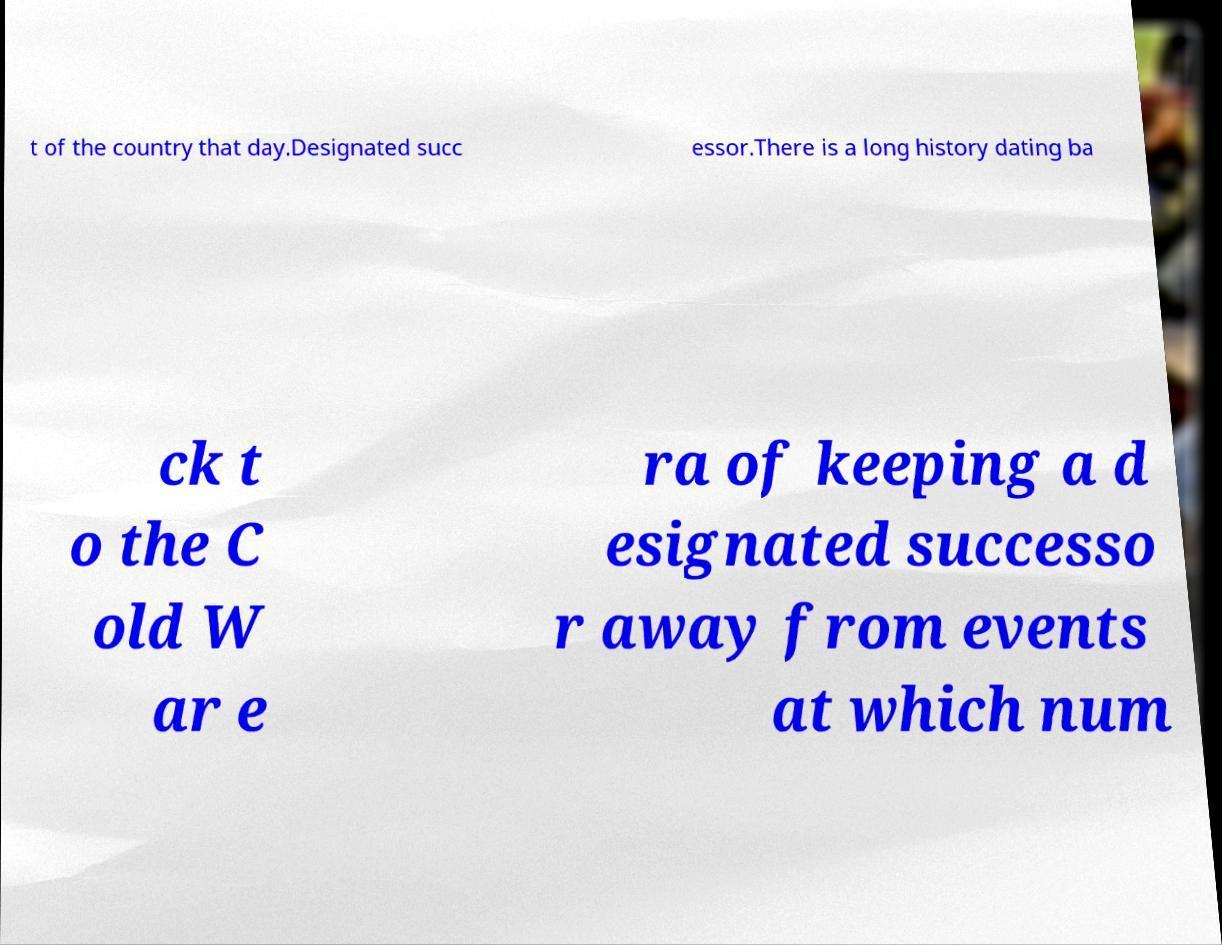Please read and relay the text visible in this image. What does it say? t of the country that day.Designated succ essor.There is a long history dating ba ck t o the C old W ar e ra of keeping a d esignated successo r away from events at which num 